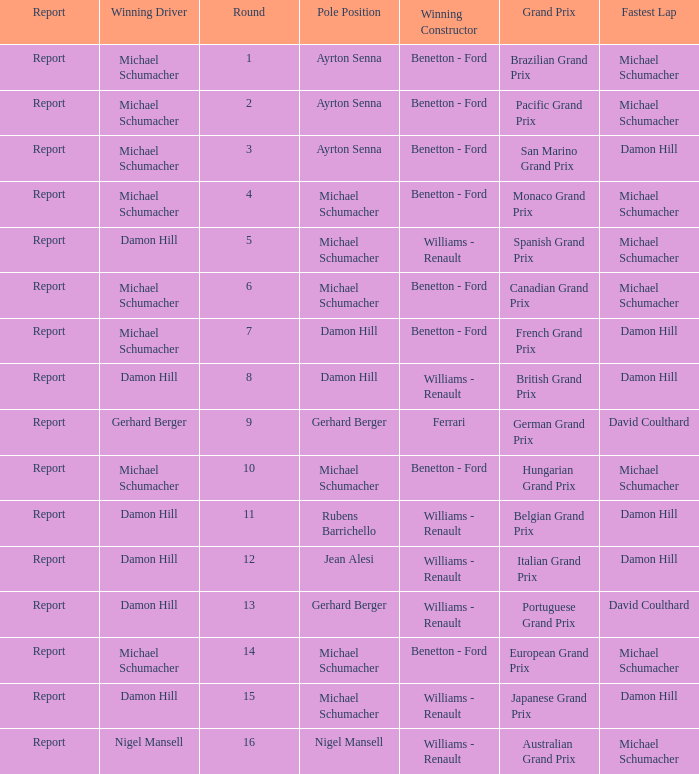Name the lowest round for when pole position and winning driver is michael schumacher 4.0. 